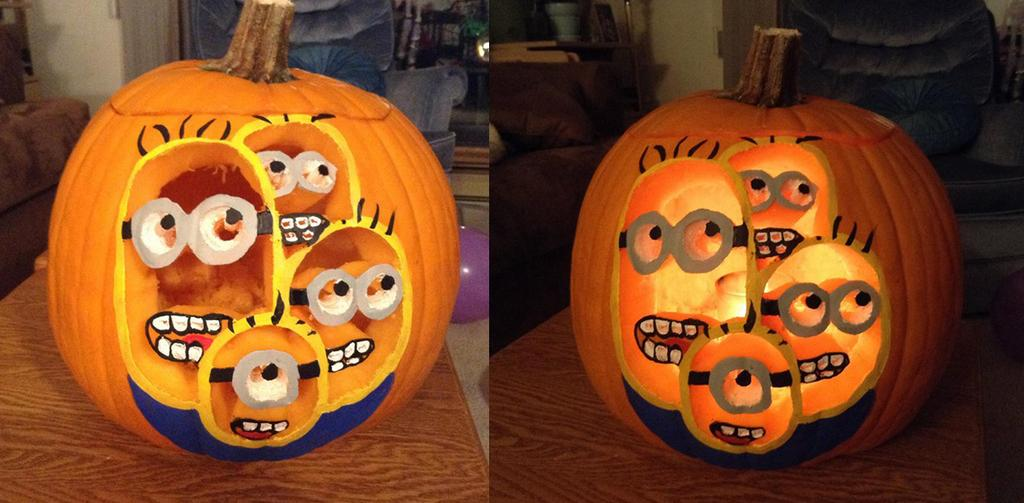What is the composition of the image? The image is a collage of two images. What objects can be seen in the collage? There are pumpkins, a balloon, and sofa chairs in the collage. How would you describe the background of the collage? The background of the collage is blurry. What is the condition of the gate in the image? There is no gate present in the image. What wish does the collage fulfill? The collage does not fulfill any specific wish, as it is a combination of images and objects. 